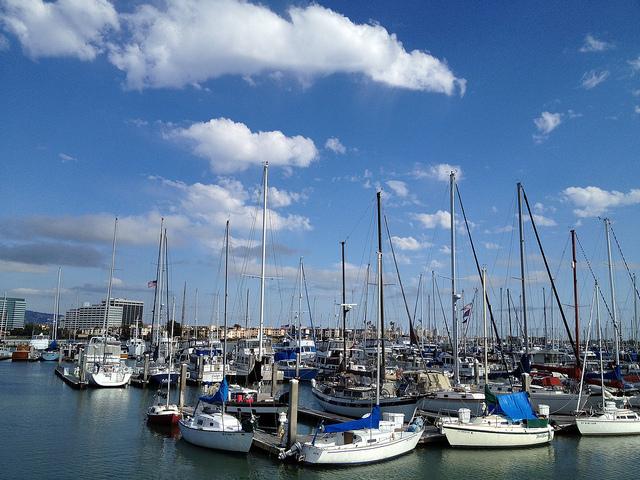Are there sailboats pictured?
Answer briefly. Yes. What flag is being flown?
Keep it brief. Usa. Are any of the sailboats moving?
Keep it brief. No. 